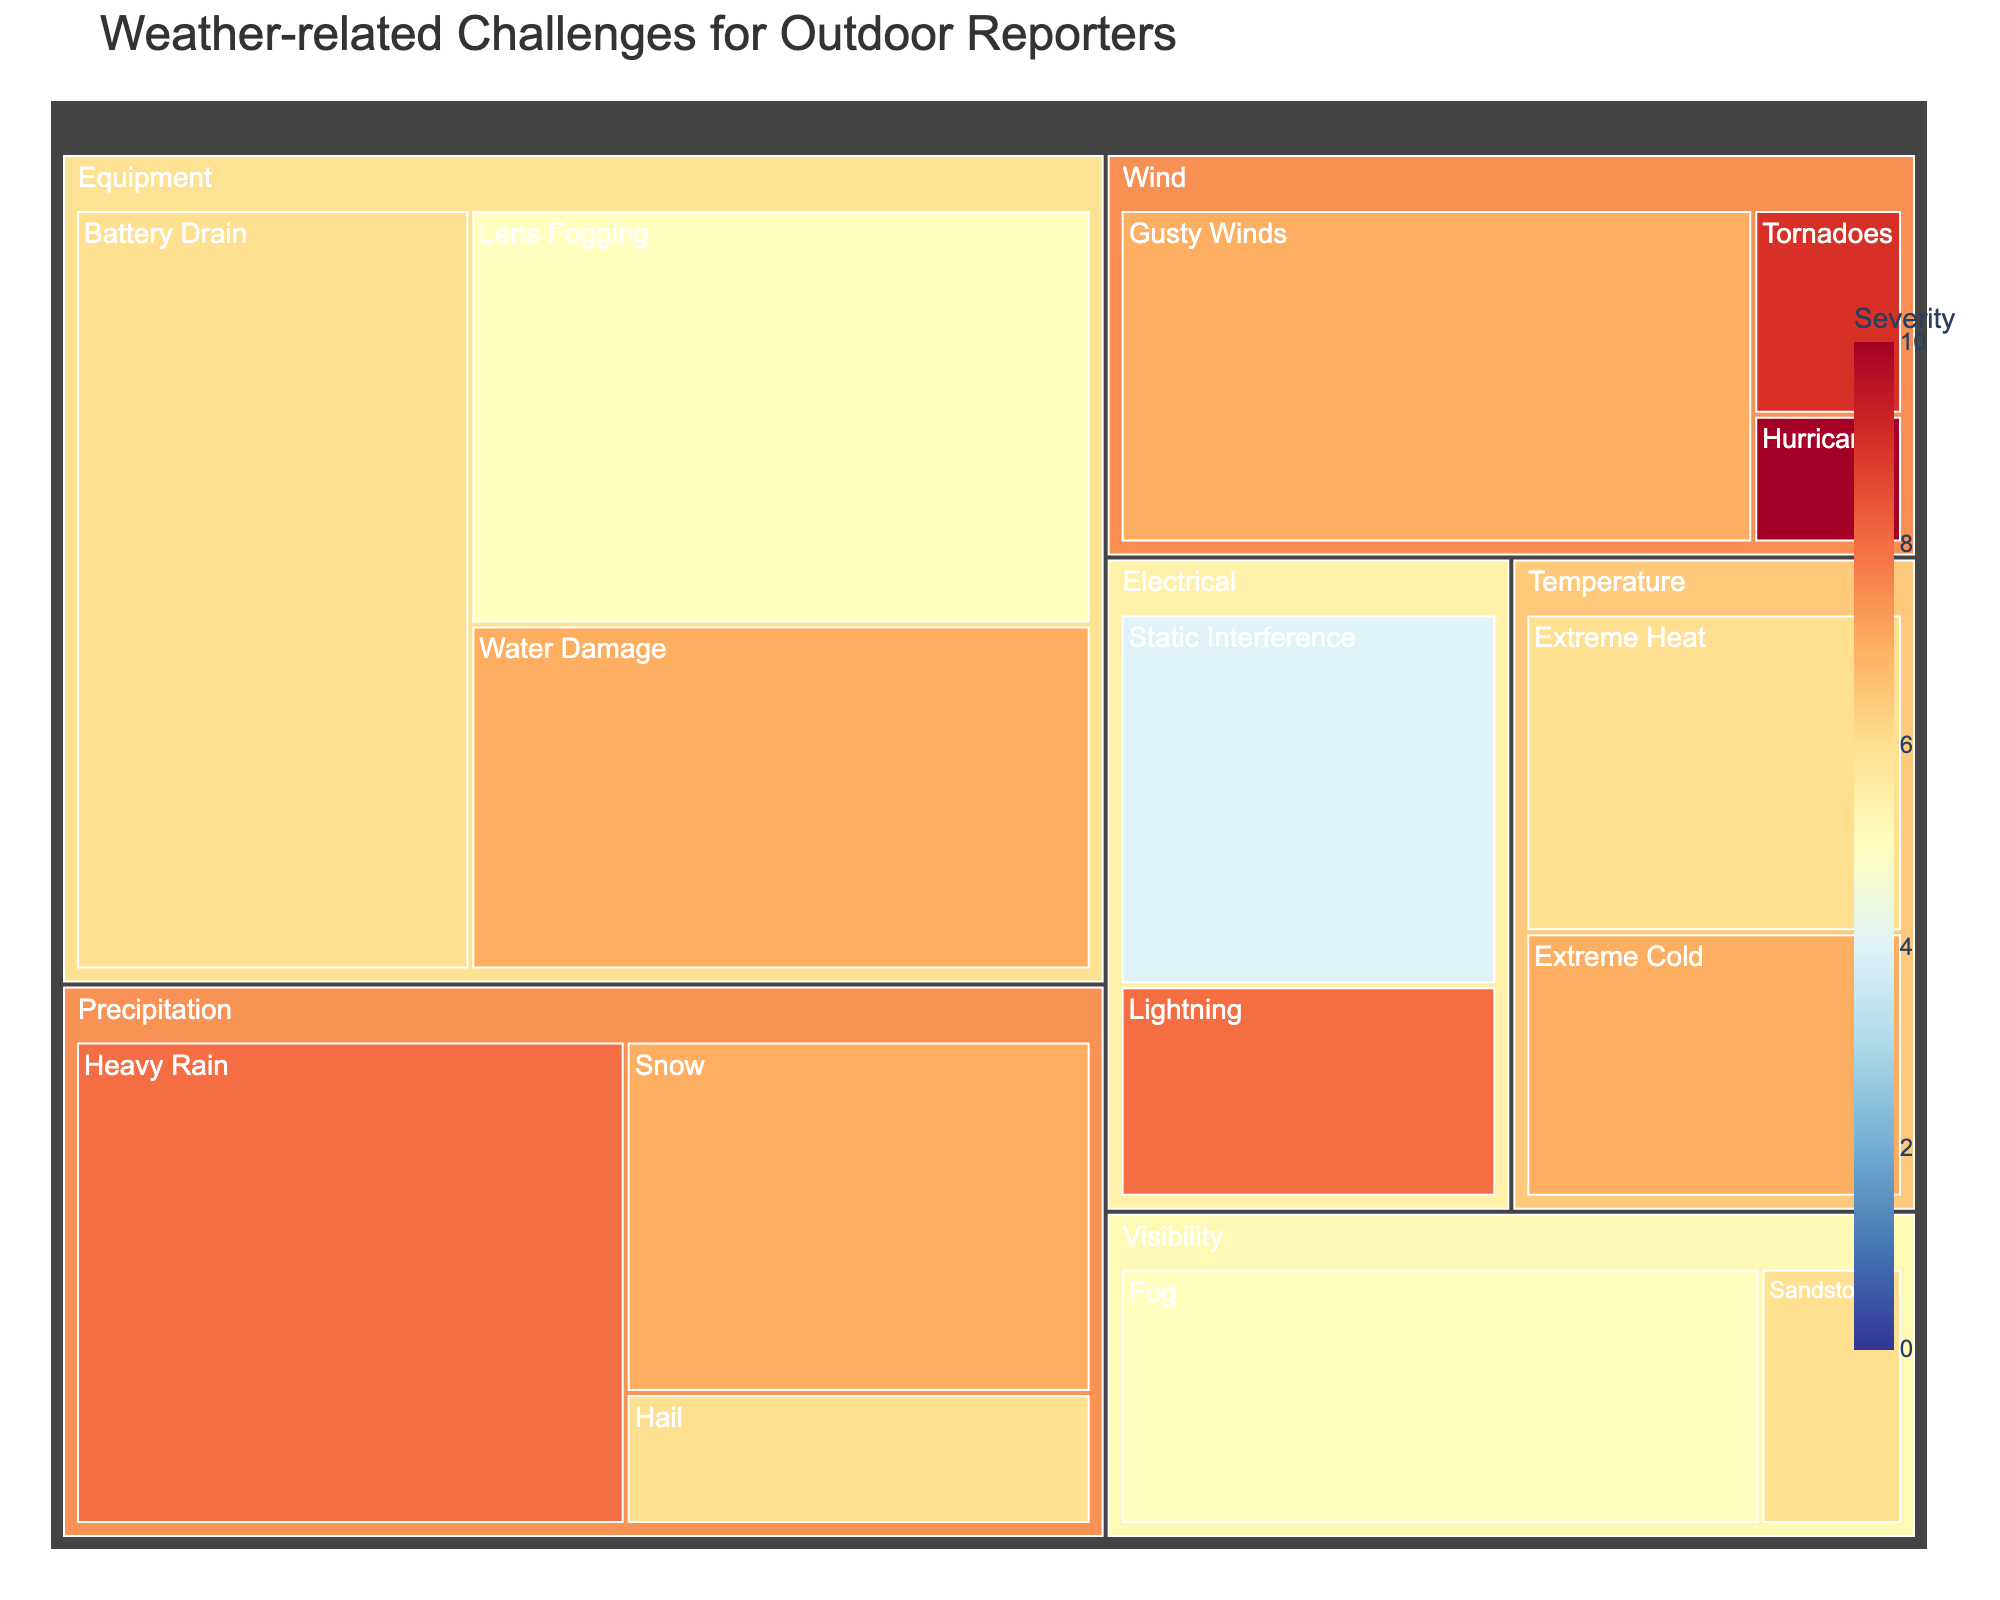How many subcategories are there under the 'Precipitation' category? The treemap shows the hierarchical categories visually. Under 'Precipitation', we can see three subcategories are present: 'Heavy Rain', 'Snow', and 'Hail'.
Answer: 3 Which weather-related challenge has the highest severity score? On the treemap, the color scale ranges from blue (low severity) to red (high severity). The challenge with the highest severity score appears in red and is 'Hurricanes' under the 'Wind' category, with a severity score of 10.
Answer: Hurricanes What is the total occurrence across all 'Temperature' subcategories? The treemap shows 'Extreme Heat' with 30 occurrences and 'Extreme Cold' with 25 occurrences. Adding them together gives 30 + 25 = 55.
Answer: 55 How does the severity of 'Heavy Rain' compare to 'Extreme Heat'? By checking the severity scores from the treemap, 'Heavy Rain' has a severity score of 8, while 'Extreme Heat' has a severity score of 6. Therefore, 'Heavy Rain' is more severe than 'Extreme Heat'.
Answer: Heavy Rain Which category has the highest cumulative occurrence value, and what is that value? Looking at all the occurrences in each category. 'Equipment' has occurrences: 50 (Water Damage), 60 (Lens Fogging), 70 (Battery Drain), so the total is 50 + 60 + 70 = 180. This is higher than any other category.
Answer: Equipment, 180 What weather-related challenge related to 'Visibility' has a higher severity score? The treemap shows two subcategories under 'Visibility': 'Fog' with a severity of 5, and 'Sandstorms' with a severity of 6. 'Sandstorms' have a higher severity score.
Answer: Sandstorms What is the average severity of all 'Wind' related challenges? The 'Wind' category has subcategories 'Gusty Winds' (7), 'Hurricanes' (10), and 'Tornadoes' (9). The average severity is calculated as (7 + 10 + 9) / 3 = 8.67.
Answer: 8.67 How many total challenges are categorized under 'Electrical'? The treemap visually categorizes challenges. Under 'Electrical', there are two subcategories: 'Lightning' and 'Static Interference'. Thus, there are 2 challenges.
Answer: 2 Among challenges related to 'Precipitation', which has the lowest occurrence? The 'Precipitation' category includes 'Heavy Rain' (65), 'Snow' (40), and 'Hail' (15). The challenge with the lowest occurrence is 'Hail'.
Answer: Hail Which subcategory in 'Equipment' has the highest occurrence? The 'Equipment' category includes subcategories 'Water Damage' (50), 'Lens Fogging' (60), and 'Battery Drain' (70). 'Battery Drain' has the highest occurrence.
Answer: Battery Drain 